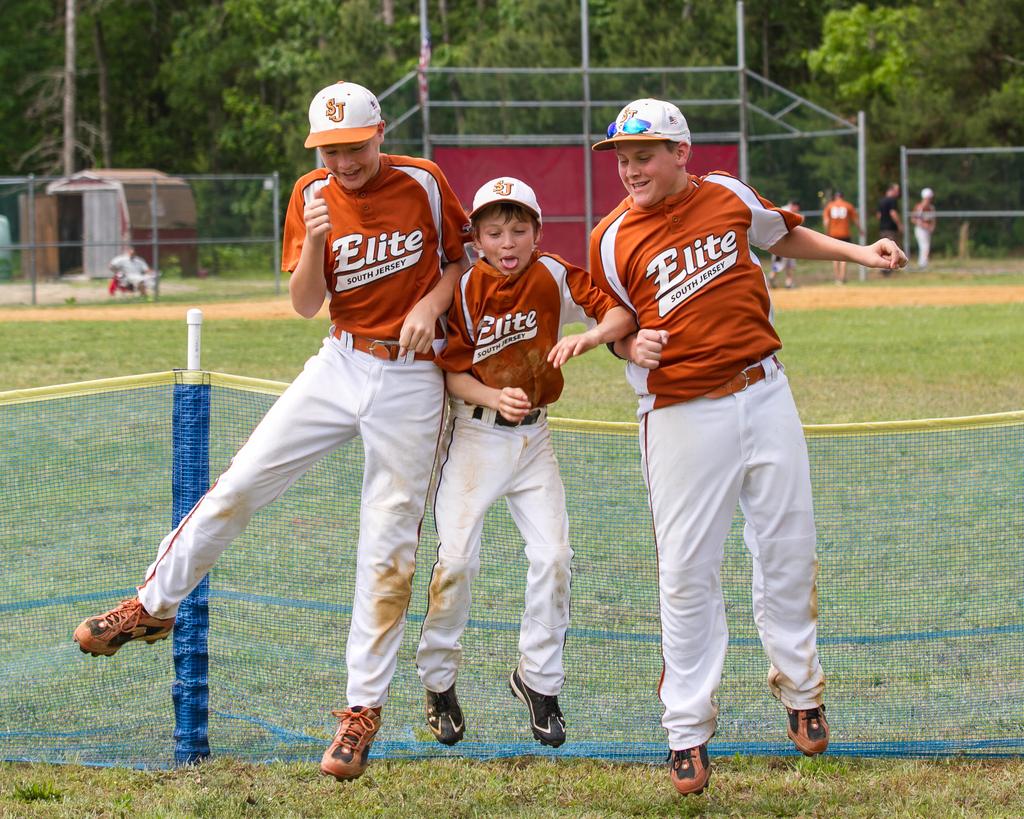What is the name of the baseball team?
Give a very brief answer. Elite. Are they from south or north jersey?
Provide a short and direct response. South. 